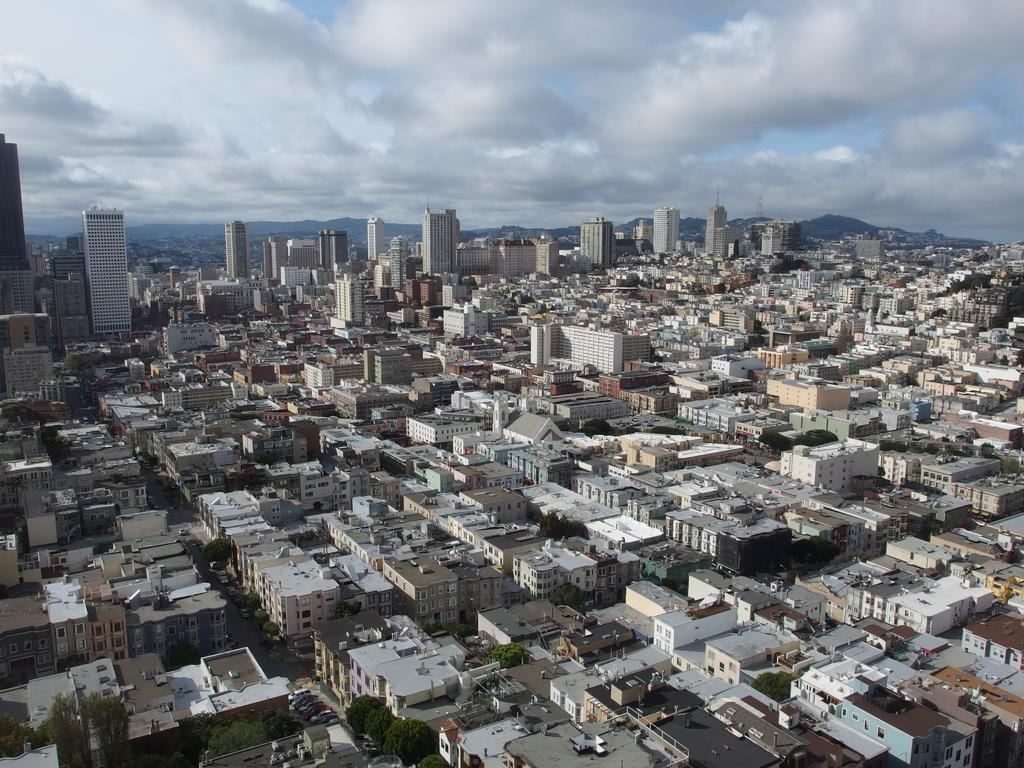What type of location is depicted in the image? The image depicts a well-developed city. What kind of structures can be seen in the city? There are plenty of houses, many buildings, and tall towers in the city. How many trees are visible in the city? There are very few trees in the city. What can be seen in the background of the image? The sky is visible in the background of the image. What type of potato is being used for magic in the image? There is no potato or magic present in the image; it depicts a well-developed city with various structures and features. 